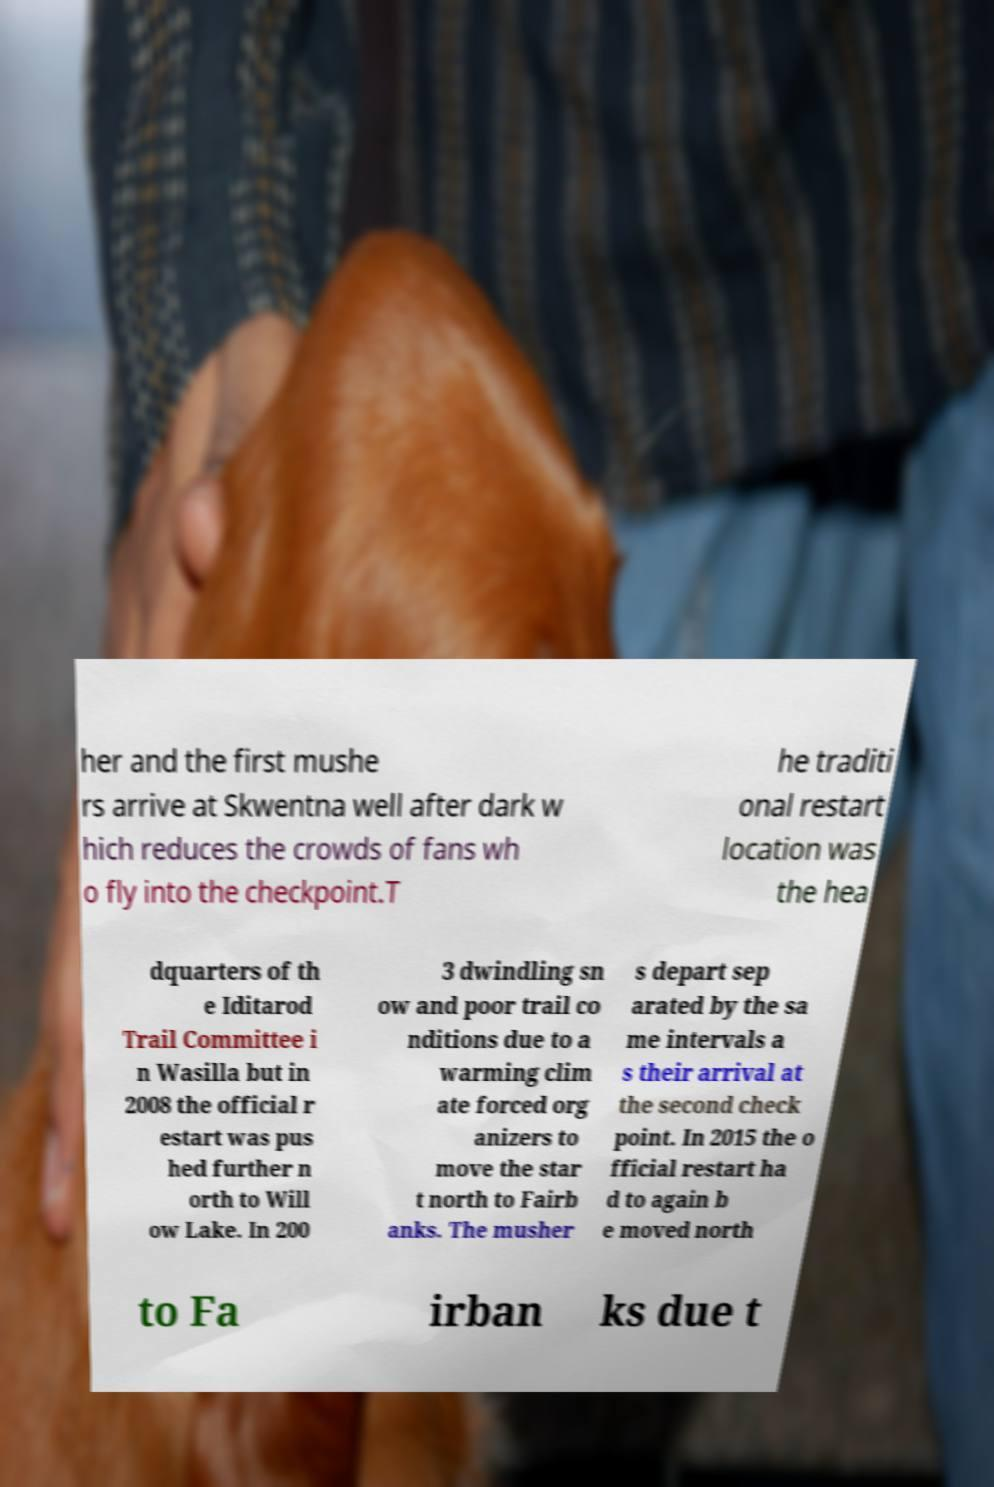Please identify and transcribe the text found in this image. her and the first mushe rs arrive at Skwentna well after dark w hich reduces the crowds of fans wh o fly into the checkpoint.T he traditi onal restart location was the hea dquarters of th e Iditarod Trail Committee i n Wasilla but in 2008 the official r estart was pus hed further n orth to Will ow Lake. In 200 3 dwindling sn ow and poor trail co nditions due to a warming clim ate forced org anizers to move the star t north to Fairb anks. The musher s depart sep arated by the sa me intervals a s their arrival at the second check point. In 2015 the o fficial restart ha d to again b e moved north to Fa irban ks due t 